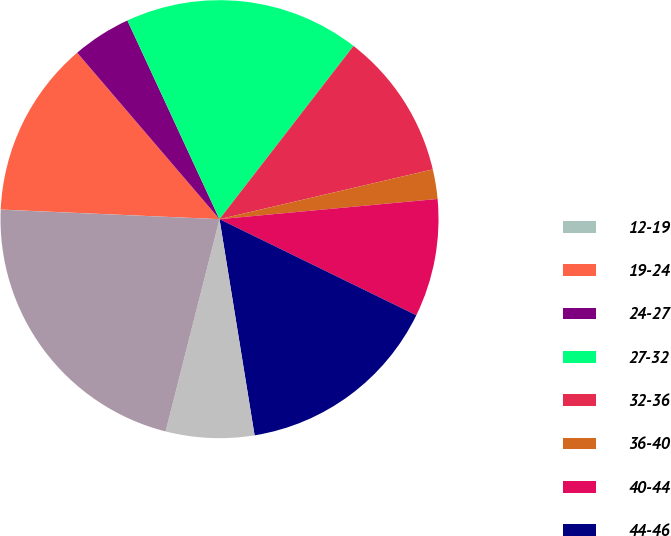Convert chart to OTSL. <chart><loc_0><loc_0><loc_500><loc_500><pie_chart><fcel>12-19<fcel>19-24<fcel>24-27<fcel>27-32<fcel>32-36<fcel>36-40<fcel>40-44<fcel>44-46<fcel>46-49<fcel>0-49<nl><fcel>0.01%<fcel>13.04%<fcel>4.35%<fcel>17.39%<fcel>10.87%<fcel>2.18%<fcel>8.7%<fcel>15.21%<fcel>6.52%<fcel>21.73%<nl></chart> 